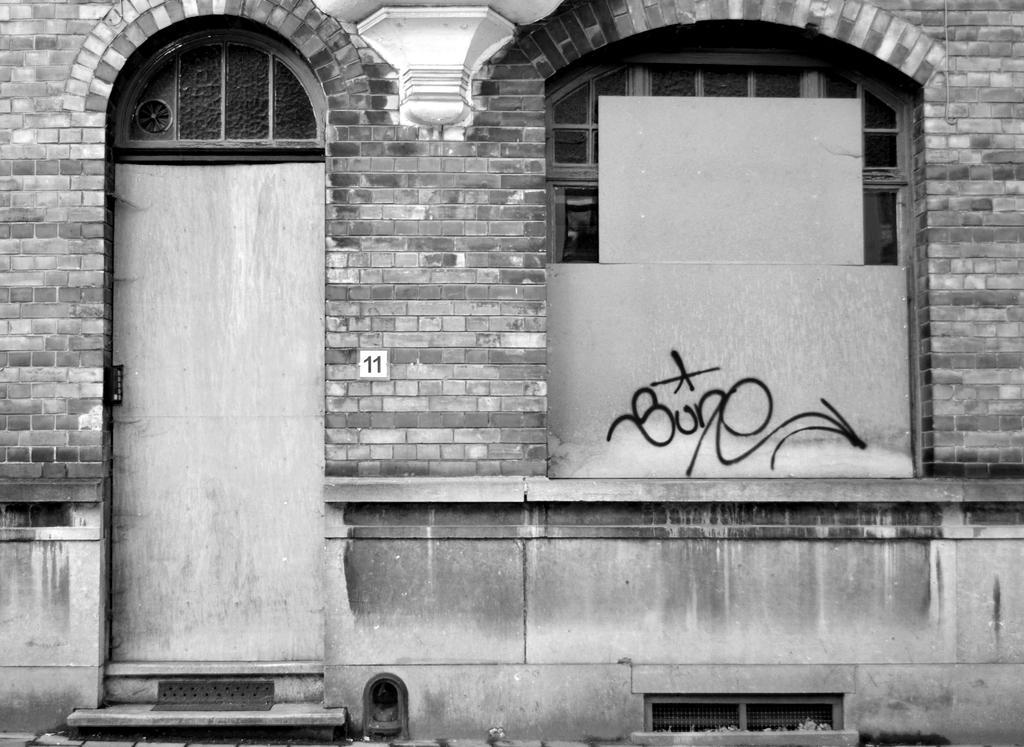In one or two sentences, can you explain what this image depicts? This image consists of a building. On the left, there is a door. On the right, we can see a window. 